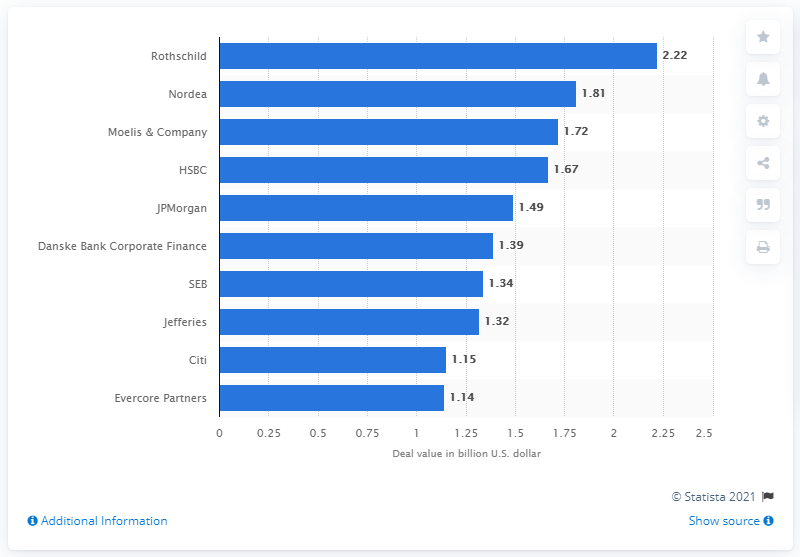Mention a couple of crucial points in this snapshot. In 2016, Rothschild was named the leading advisor to M&A deals in Denmark. In 2016, the value of Rothschild's deals was approximately 2.22. 